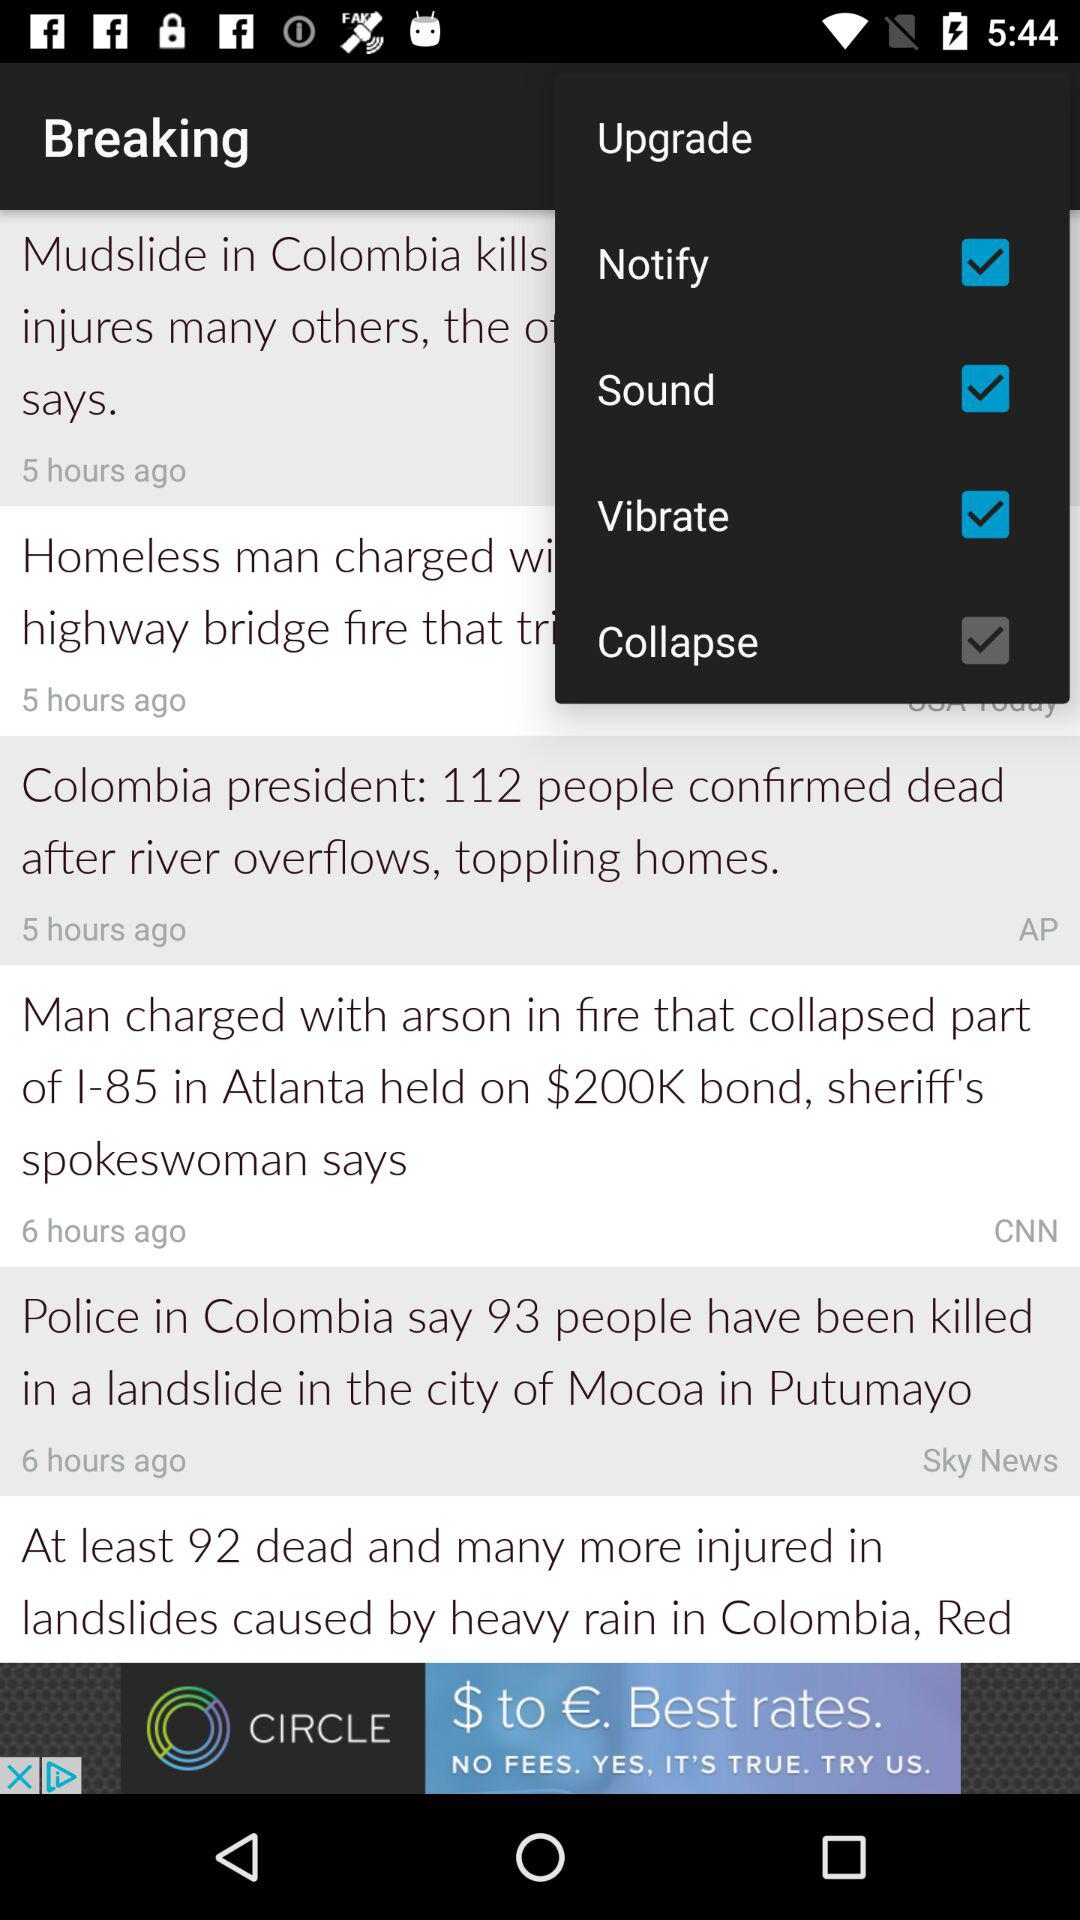What is the status of "Upgrade"?
When the provided information is insufficient, respond with <no answer>. <no answer> 